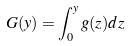Convert formula to latex. <formula><loc_0><loc_0><loc_500><loc_500>G ( y ) = \int _ { 0 } ^ { y } g ( z ) d z</formula> 